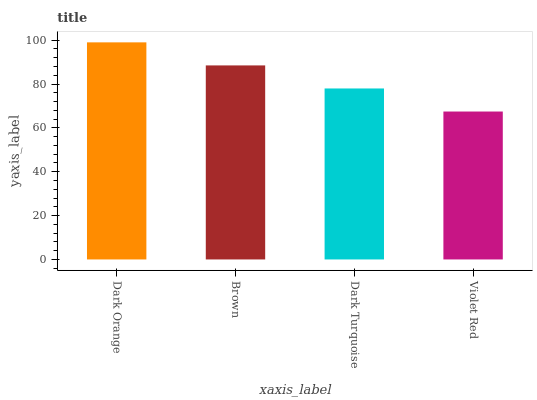Is Violet Red the minimum?
Answer yes or no. Yes. Is Dark Orange the maximum?
Answer yes or no. Yes. Is Brown the minimum?
Answer yes or no. No. Is Brown the maximum?
Answer yes or no. No. Is Dark Orange greater than Brown?
Answer yes or no. Yes. Is Brown less than Dark Orange?
Answer yes or no. Yes. Is Brown greater than Dark Orange?
Answer yes or no. No. Is Dark Orange less than Brown?
Answer yes or no. No. Is Brown the high median?
Answer yes or no. Yes. Is Dark Turquoise the low median?
Answer yes or no. Yes. Is Violet Red the high median?
Answer yes or no. No. Is Dark Orange the low median?
Answer yes or no. No. 